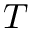<formula> <loc_0><loc_0><loc_500><loc_500>T</formula> 